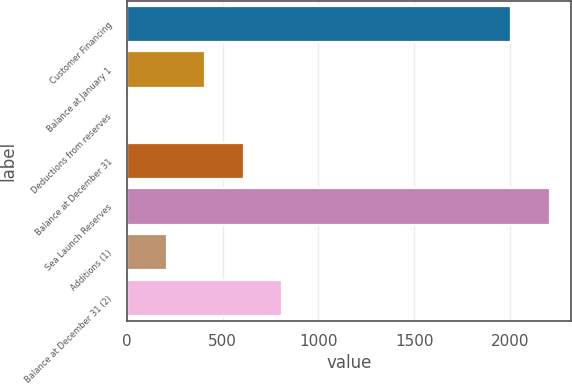<chart> <loc_0><loc_0><loc_500><loc_500><bar_chart><fcel>Customer Financing<fcel>Balance at January 1<fcel>Deductions from reserves<fcel>Balance at December 31<fcel>Sea Launch Reserves<fcel>Additions (1)<fcel>Balance at December 31 (2)<nl><fcel>2008<fcel>409.6<fcel>10<fcel>609.4<fcel>2207.8<fcel>209.8<fcel>809.2<nl></chart> 